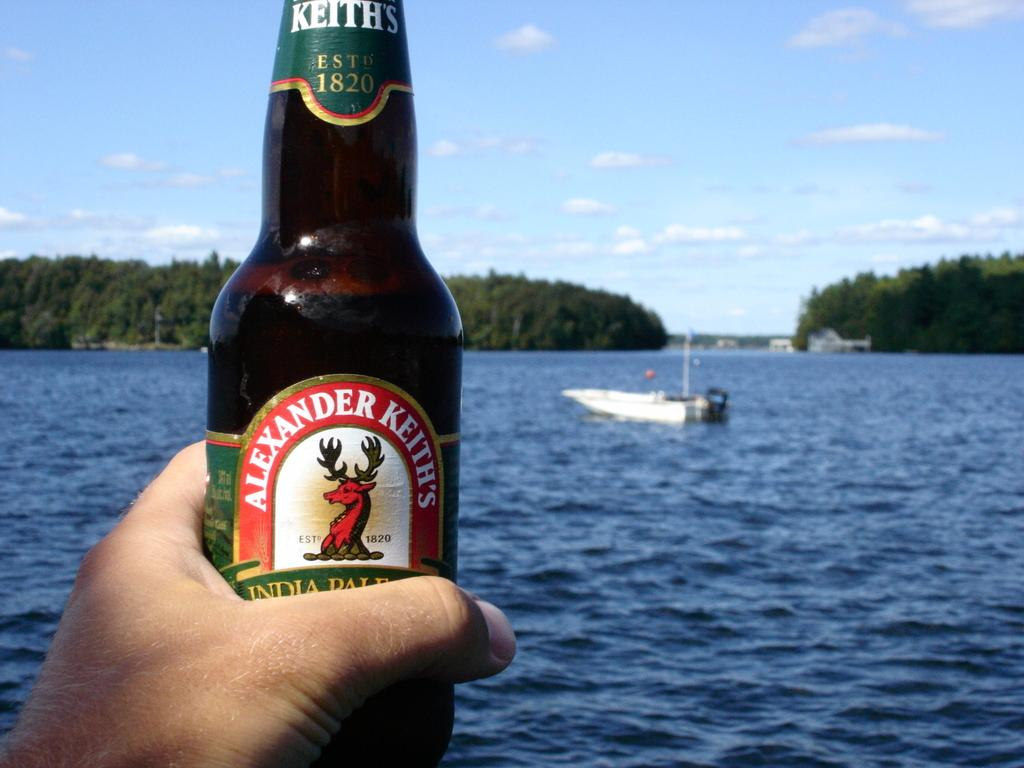<image>
Relay a brief, clear account of the picture shown. A bottle of Alexander Keith's is held in a hand in front of a body of water. 